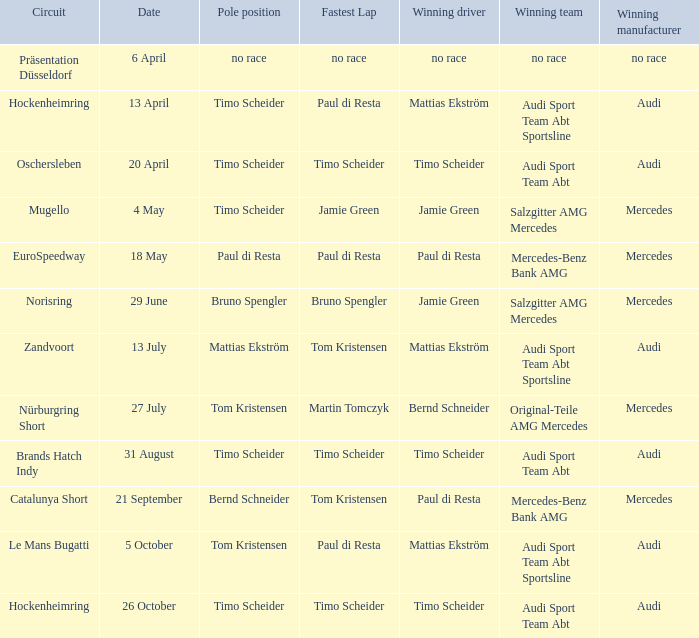Who is the winning driver of the race with no race as the winning manufacturer? No race. 